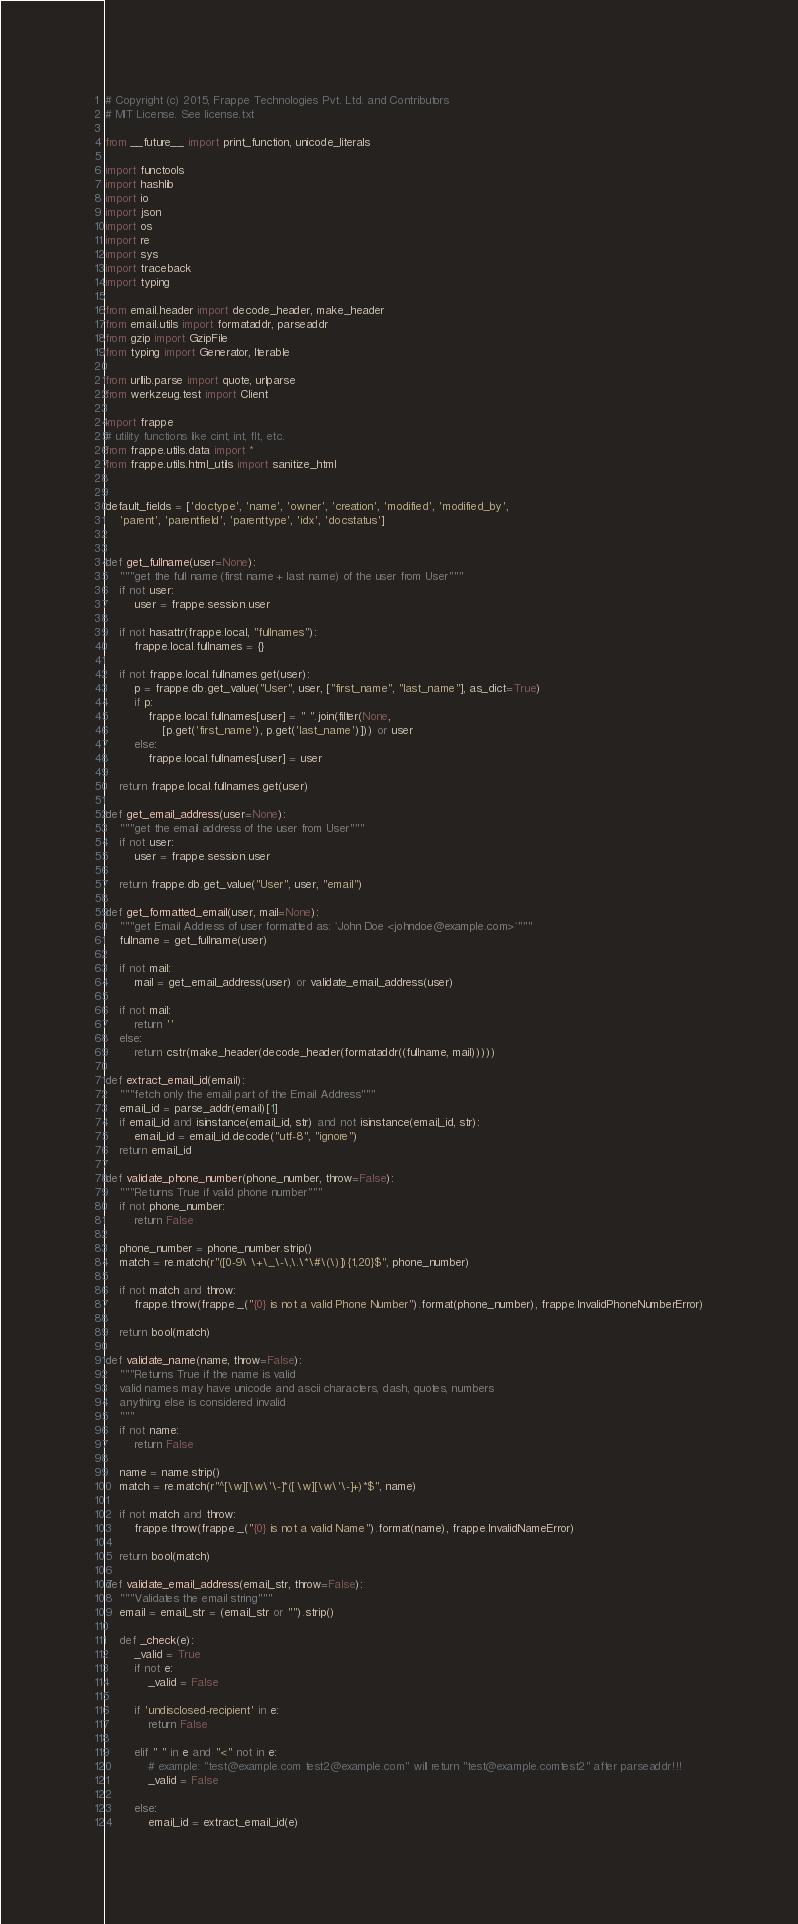<code> <loc_0><loc_0><loc_500><loc_500><_Python_># Copyright (c) 2015, Frappe Technologies Pvt. Ltd. and Contributors
# MIT License. See license.txt

from __future__ import print_function, unicode_literals

import functools
import hashlib
import io
import json
import os
import re
import sys
import traceback
import typing

from email.header import decode_header, make_header
from email.utils import formataddr, parseaddr
from gzip import GzipFile
from typing import Generator, Iterable

from urllib.parse import quote, urlparse
from werkzeug.test import Client

import frappe
# utility functions like cint, int, flt, etc.
from frappe.utils.data import *
from frappe.utils.html_utils import sanitize_html


default_fields = ['doctype', 'name', 'owner', 'creation', 'modified', 'modified_by',
	'parent', 'parentfield', 'parenttype', 'idx', 'docstatus']


def get_fullname(user=None):
	"""get the full name (first name + last name) of the user from User"""
	if not user:
		user = frappe.session.user

	if not hasattr(frappe.local, "fullnames"):
		frappe.local.fullnames = {}

	if not frappe.local.fullnames.get(user):
		p = frappe.db.get_value("User", user, ["first_name", "last_name"], as_dict=True)
		if p:
			frappe.local.fullnames[user] = " ".join(filter(None,
				[p.get('first_name'), p.get('last_name')])) or user
		else:
			frappe.local.fullnames[user] = user

	return frappe.local.fullnames.get(user)

def get_email_address(user=None):
	"""get the email address of the user from User"""
	if not user:
		user = frappe.session.user

	return frappe.db.get_value("User", user, "email")

def get_formatted_email(user, mail=None):
	"""get Email Address of user formatted as: `John Doe <johndoe@example.com>`"""
	fullname = get_fullname(user)

	if not mail:
		mail = get_email_address(user) or validate_email_address(user)

	if not mail:
		return ''
	else:
		return cstr(make_header(decode_header(formataddr((fullname, mail)))))

def extract_email_id(email):
	"""fetch only the email part of the Email Address"""
	email_id = parse_addr(email)[1]
	if email_id and isinstance(email_id, str) and not isinstance(email_id, str):
		email_id = email_id.decode("utf-8", "ignore")
	return email_id

def validate_phone_number(phone_number, throw=False):
	"""Returns True if valid phone number"""
	if not phone_number:
		return False

	phone_number = phone_number.strip()
	match = re.match(r"([0-9\ \+\_\-\,\.\*\#\(\)]){1,20}$", phone_number)

	if not match and throw:
		frappe.throw(frappe._("{0} is not a valid Phone Number").format(phone_number), frappe.InvalidPhoneNumberError)

	return bool(match)

def validate_name(name, throw=False):
	"""Returns True if the name is valid
	valid names may have unicode and ascii characters, dash, quotes, numbers
	anything else is considered invalid
	"""
	if not name:
		return False

	name = name.strip()
	match = re.match(r"^[\w][\w\'\-]*([ \w][\w\'\-]+)*$", name)

	if not match and throw:
		frappe.throw(frappe._("{0} is not a valid Name").format(name), frappe.InvalidNameError)

	return bool(match)

def validate_email_address(email_str, throw=False):
	"""Validates the email string"""
	email = email_str = (email_str or "").strip()

	def _check(e):
		_valid = True
		if not e:
			_valid = False

		if 'undisclosed-recipient' in e:
			return False

		elif " " in e and "<" not in e:
			# example: "test@example.com test2@example.com" will return "test@example.comtest2" after parseaddr!!!
			_valid = False

		else:
			email_id = extract_email_id(e)</code> 